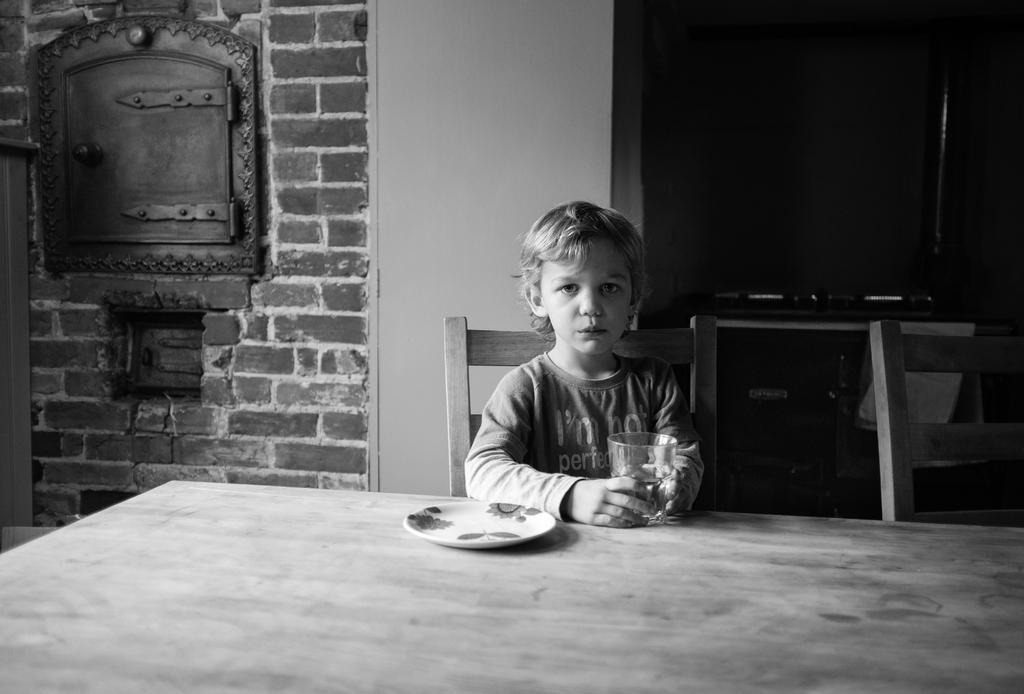Could you give a brief overview of what you see in this image? He is sitting on a chair. He's holding a glass,There is a table. There is a plate,glass on a table. We can see the background there is a red color wall bricks. 